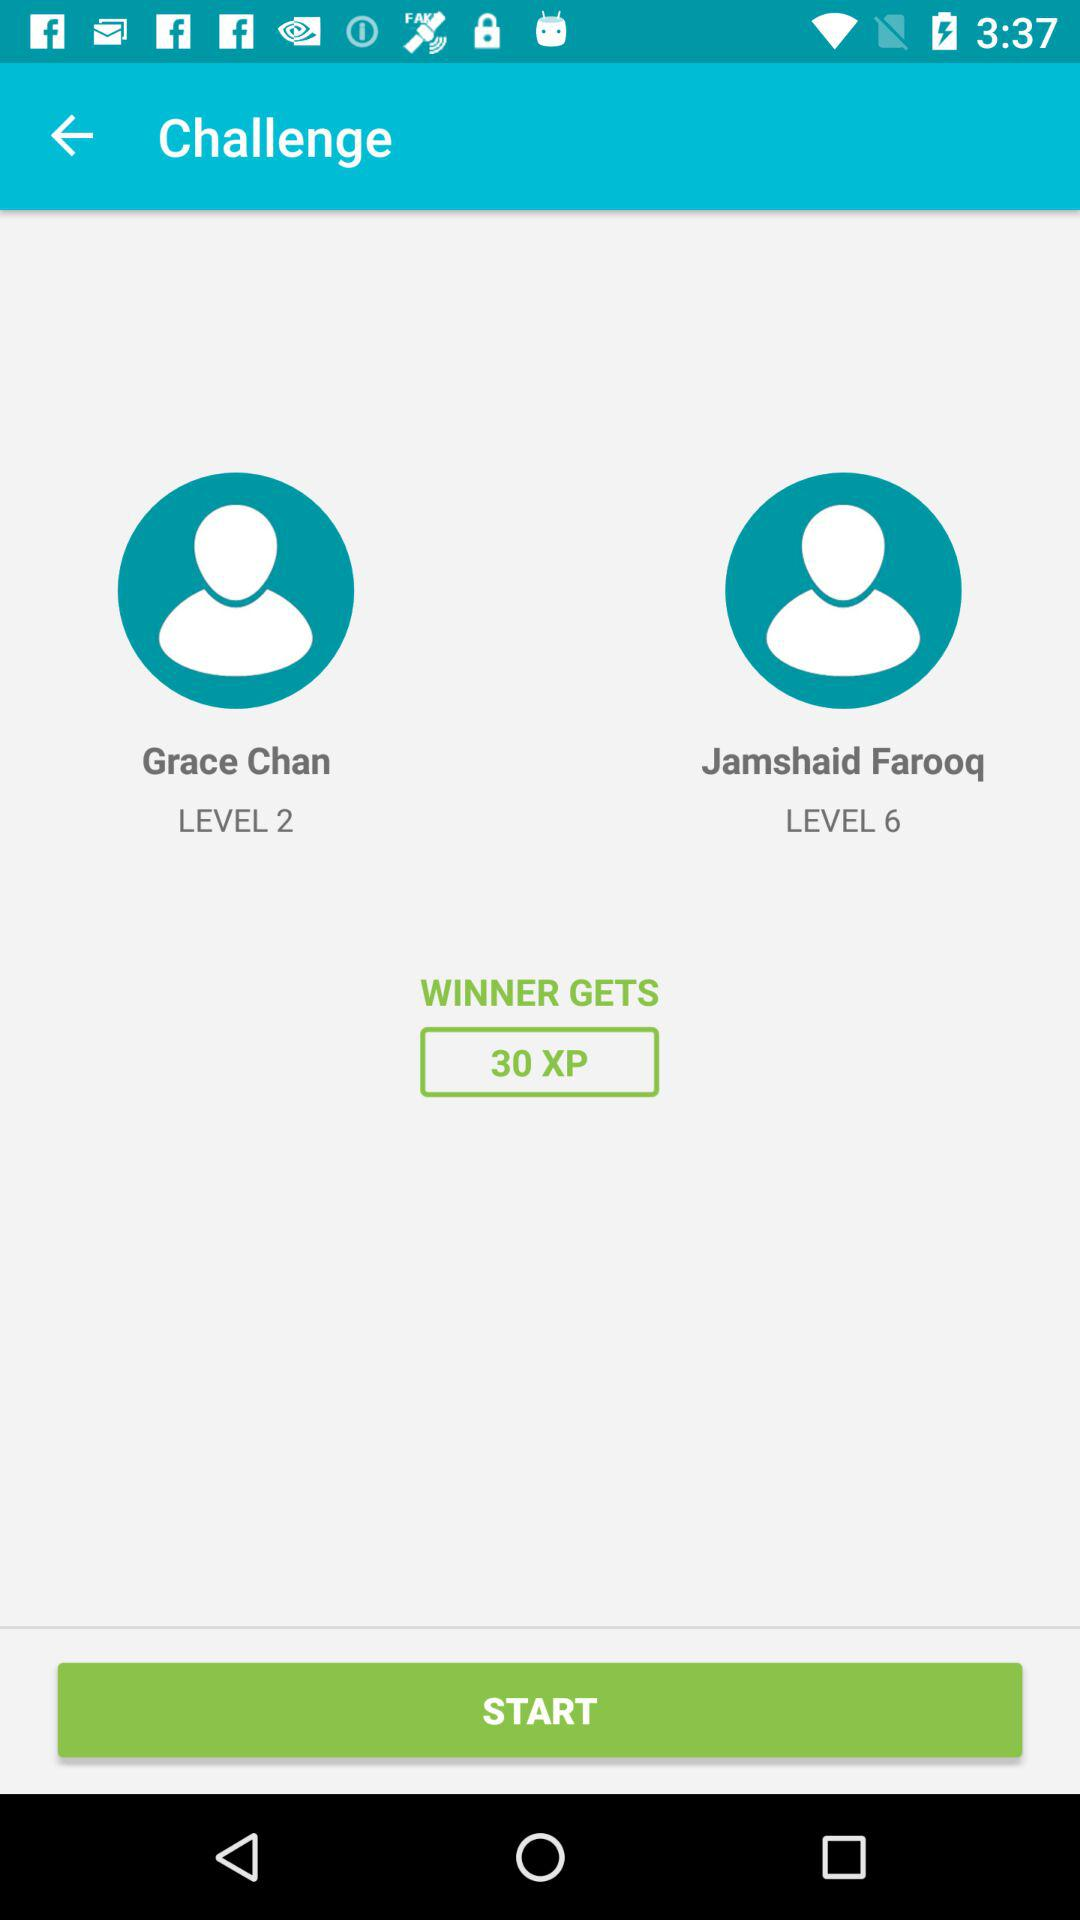How much XP does the winner get?
Answer the question using a single word or phrase. 30 